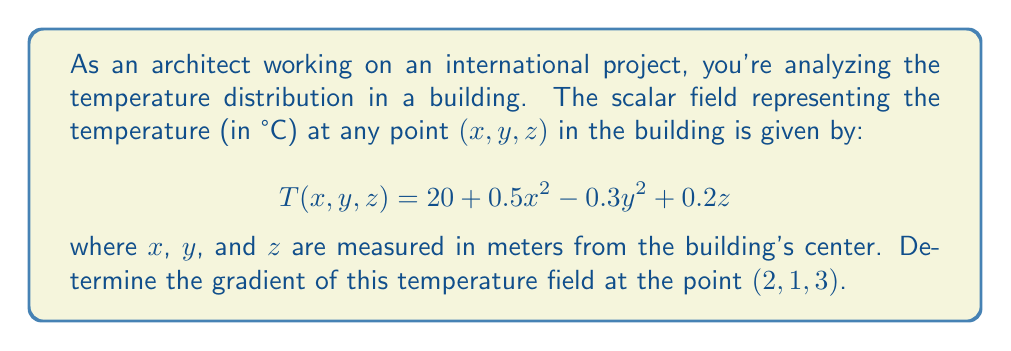Help me with this question. To solve this problem, we need to follow these steps:

1) The gradient of a scalar field $T(x,y,z)$ is defined as:

   $$\nabla T = \left(\frac{\partial T}{\partial x}, \frac{\partial T}{\partial y}, \frac{\partial T}{\partial z}\right)$$

2) Let's calculate each partial derivative:

   $$\frac{\partial T}{\partial x} = 0.5 \cdot 2x = x$$
   
   $$\frac{\partial T}{\partial y} = -0.3 \cdot 2y = -0.6y$$
   
   $$\frac{\partial T}{\partial z} = 0.2$$

3) Now we can write the gradient as a function:

   $$\nabla T(x,y,z) = (x, -0.6y, 0.2)$$

4) To find the gradient at the point $(2, 1, 3)$, we simply substitute these values:

   $$\nabla T(2, 1, 3) = (2, -0.6 \cdot 1, 0.2) = (2, -0.6, 0.2)$$

This gradient vector indicates the direction of the steepest increase in temperature at the point (2, 1, 3) and its magnitude represents the rate of that increase.
Answer: $(2, -0.6, 0.2)$ 